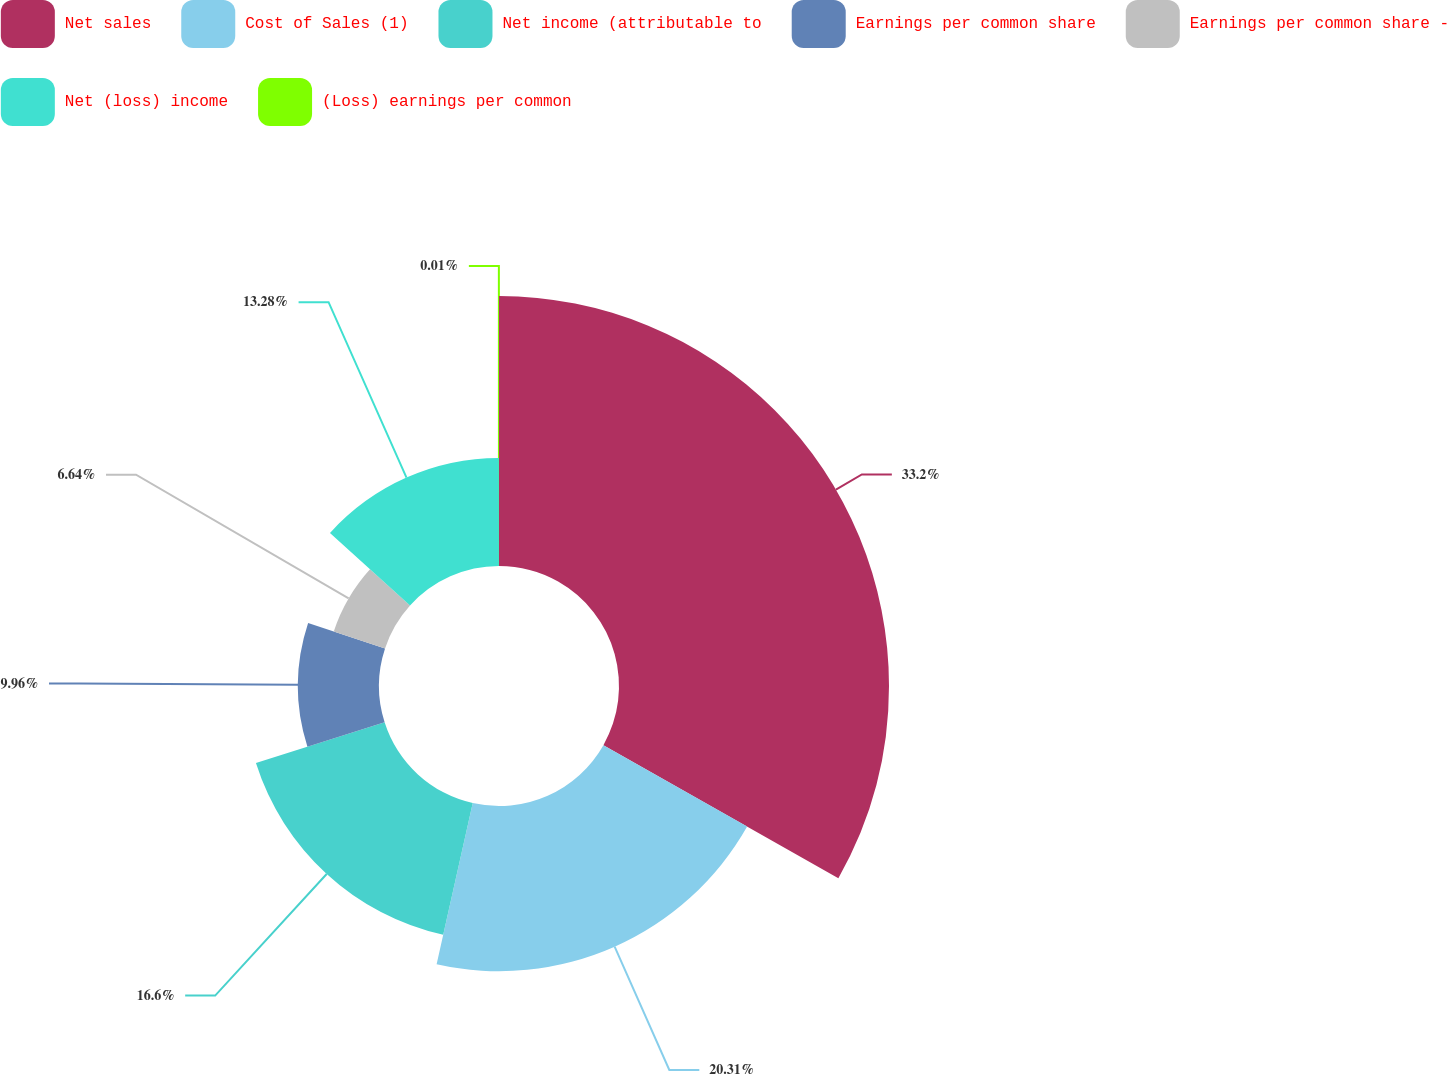Convert chart. <chart><loc_0><loc_0><loc_500><loc_500><pie_chart><fcel>Net sales<fcel>Cost of Sales (1)<fcel>Net income (attributable to<fcel>Earnings per common share<fcel>Earnings per common share -<fcel>Net (loss) income<fcel>(Loss) earnings per common<nl><fcel>33.2%<fcel>20.31%<fcel>16.6%<fcel>9.96%<fcel>6.64%<fcel>13.28%<fcel>0.01%<nl></chart> 